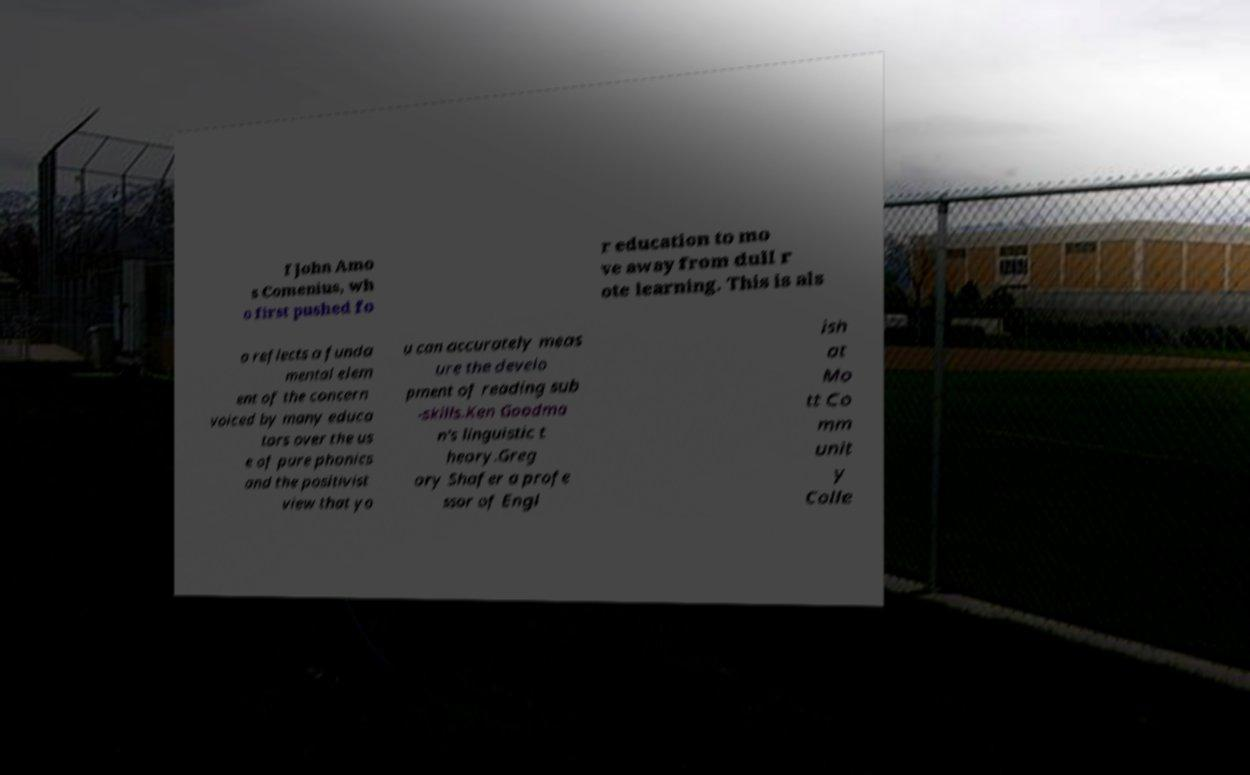Can you read and provide the text displayed in the image?This photo seems to have some interesting text. Can you extract and type it out for me? f John Amo s Comenius, wh o first pushed fo r education to mo ve away from dull r ote learning. This is als o reflects a funda mental elem ent of the concern voiced by many educa tors over the us e of pure phonics and the positivist view that yo u can accurately meas ure the develo pment of reading sub -skills.Ken Goodma n's linguistic t heory.Greg ory Shafer a profe ssor of Engl ish at Mo tt Co mm unit y Colle 